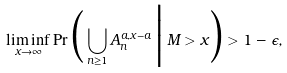Convert formula to latex. <formula><loc_0><loc_0><loc_500><loc_500>\liminf _ { x \to \infty } \Pr \Big ( \bigcup _ { n \geq 1 } A _ { n } ^ { a , x - a } \, \Big | \, M > x \Big ) > 1 - \epsilon ,</formula> 